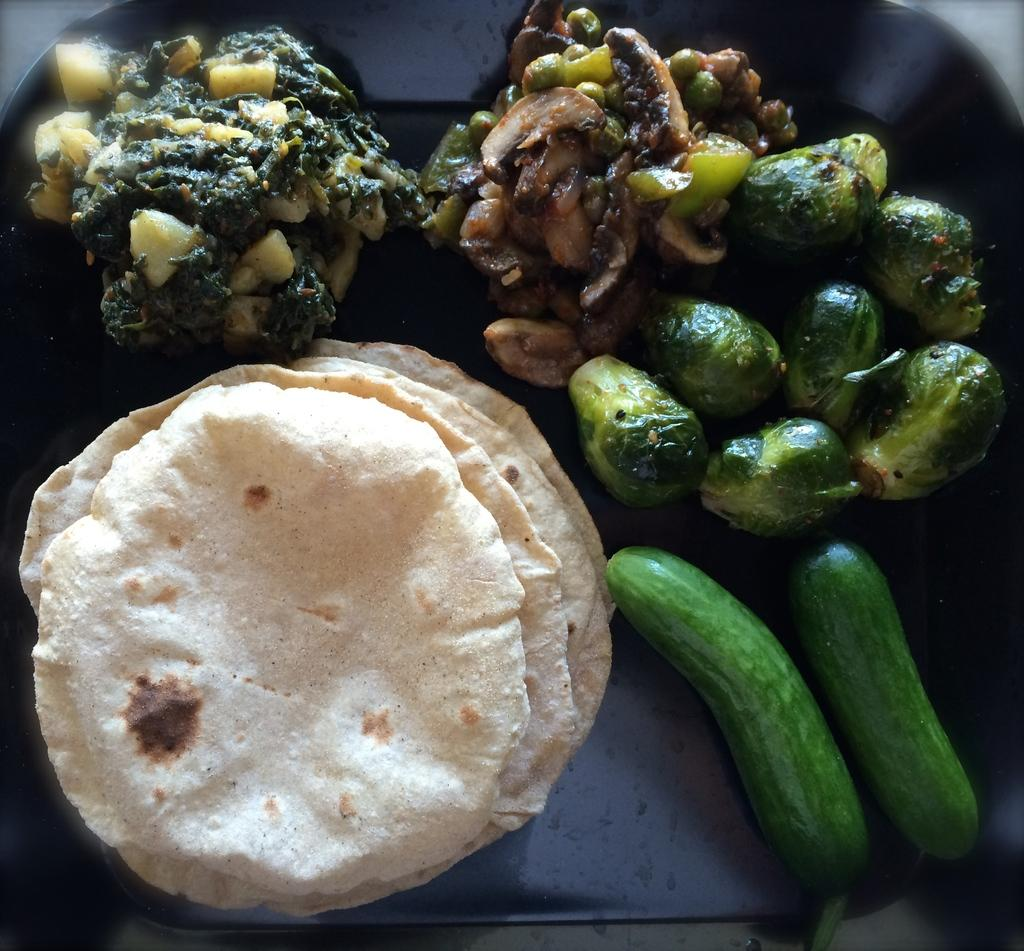What is present in the image? There is a bowl in the image. What is inside the bowl? There is a food item in the bowl. Can you see any goldfish swimming in the juice in the image? There is no juice or goldfish present in the image; it only features a bowl with a food item inside. 